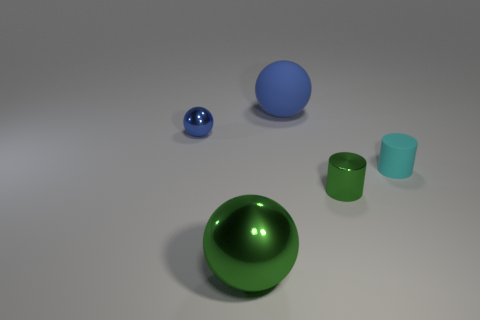What number of blocks are tiny red things or large things?
Make the answer very short. 0. What color is the other object that is made of the same material as the big blue thing?
Ensure brevity in your answer.  Cyan. Is the material of the cyan thing the same as the big ball that is in front of the cyan rubber object?
Your response must be concise. No. What number of objects are either rubber cylinders or large brown shiny objects?
Ensure brevity in your answer.  1. There is a big thing that is the same color as the tiny ball; what material is it?
Your response must be concise. Rubber. Is there a small blue shiny thing of the same shape as the tiny green shiny thing?
Your answer should be very brief. No. What number of tiny cyan objects are on the left side of the big blue matte thing?
Your response must be concise. 0. There is a blue ball that is on the left side of the large ball that is in front of the big matte object; what is it made of?
Make the answer very short. Metal. There is a cyan cylinder that is the same size as the green metal cylinder; what material is it?
Ensure brevity in your answer.  Rubber. Are there any green rubber cubes that have the same size as the rubber sphere?
Keep it short and to the point. No. 